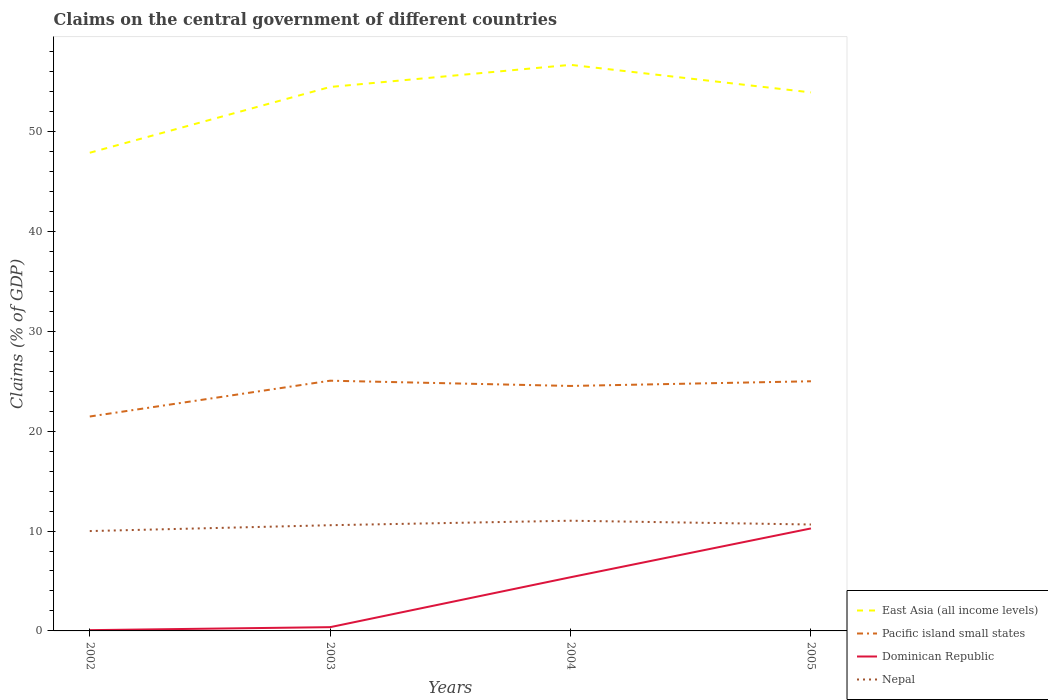How many different coloured lines are there?
Provide a short and direct response. 4. Does the line corresponding to East Asia (all income levels) intersect with the line corresponding to Nepal?
Your response must be concise. No. Across all years, what is the maximum percentage of GDP claimed on the central government in Pacific island small states?
Provide a short and direct response. 21.46. In which year was the percentage of GDP claimed on the central government in Nepal maximum?
Make the answer very short. 2002. What is the total percentage of GDP claimed on the central government in East Asia (all income levels) in the graph?
Your response must be concise. -2.21. What is the difference between the highest and the second highest percentage of GDP claimed on the central government in Pacific island small states?
Your answer should be compact. 3.58. What is the difference between the highest and the lowest percentage of GDP claimed on the central government in East Asia (all income levels)?
Make the answer very short. 3. How many lines are there?
Keep it short and to the point. 4. How many years are there in the graph?
Keep it short and to the point. 4. Are the values on the major ticks of Y-axis written in scientific E-notation?
Make the answer very short. No. Does the graph contain grids?
Offer a terse response. No. Where does the legend appear in the graph?
Keep it short and to the point. Bottom right. How many legend labels are there?
Provide a short and direct response. 4. What is the title of the graph?
Give a very brief answer. Claims on the central government of different countries. Does "Benin" appear as one of the legend labels in the graph?
Your answer should be very brief. No. What is the label or title of the X-axis?
Provide a short and direct response. Years. What is the label or title of the Y-axis?
Your answer should be very brief. Claims (% of GDP). What is the Claims (% of GDP) in East Asia (all income levels) in 2002?
Your answer should be very brief. 47.87. What is the Claims (% of GDP) of Pacific island small states in 2002?
Your response must be concise. 21.46. What is the Claims (% of GDP) in Dominican Republic in 2002?
Provide a succinct answer. 0.08. What is the Claims (% of GDP) of Nepal in 2002?
Provide a succinct answer. 10. What is the Claims (% of GDP) of East Asia (all income levels) in 2003?
Keep it short and to the point. 54.45. What is the Claims (% of GDP) in Pacific island small states in 2003?
Keep it short and to the point. 25.05. What is the Claims (% of GDP) in Dominican Republic in 2003?
Provide a short and direct response. 0.38. What is the Claims (% of GDP) in Nepal in 2003?
Give a very brief answer. 10.58. What is the Claims (% of GDP) in East Asia (all income levels) in 2004?
Your answer should be very brief. 56.67. What is the Claims (% of GDP) of Pacific island small states in 2004?
Keep it short and to the point. 24.52. What is the Claims (% of GDP) of Dominican Republic in 2004?
Your answer should be compact. 5.37. What is the Claims (% of GDP) of Nepal in 2004?
Ensure brevity in your answer.  11.03. What is the Claims (% of GDP) of East Asia (all income levels) in 2005?
Your response must be concise. 53.91. What is the Claims (% of GDP) of Pacific island small states in 2005?
Provide a succinct answer. 24.99. What is the Claims (% of GDP) of Dominican Republic in 2005?
Give a very brief answer. 10.26. What is the Claims (% of GDP) in Nepal in 2005?
Your response must be concise. 10.65. Across all years, what is the maximum Claims (% of GDP) of East Asia (all income levels)?
Keep it short and to the point. 56.67. Across all years, what is the maximum Claims (% of GDP) in Pacific island small states?
Make the answer very short. 25.05. Across all years, what is the maximum Claims (% of GDP) in Dominican Republic?
Give a very brief answer. 10.26. Across all years, what is the maximum Claims (% of GDP) in Nepal?
Your answer should be very brief. 11.03. Across all years, what is the minimum Claims (% of GDP) in East Asia (all income levels)?
Offer a very short reply. 47.87. Across all years, what is the minimum Claims (% of GDP) of Pacific island small states?
Offer a very short reply. 21.46. Across all years, what is the minimum Claims (% of GDP) in Dominican Republic?
Ensure brevity in your answer.  0.08. Across all years, what is the minimum Claims (% of GDP) in Nepal?
Give a very brief answer. 10. What is the total Claims (% of GDP) of East Asia (all income levels) in the graph?
Provide a short and direct response. 212.89. What is the total Claims (% of GDP) of Pacific island small states in the graph?
Your response must be concise. 96.02. What is the total Claims (% of GDP) of Dominican Republic in the graph?
Provide a succinct answer. 16.08. What is the total Claims (% of GDP) in Nepal in the graph?
Provide a short and direct response. 42.26. What is the difference between the Claims (% of GDP) of East Asia (all income levels) in 2002 and that in 2003?
Make the answer very short. -6.58. What is the difference between the Claims (% of GDP) of Pacific island small states in 2002 and that in 2003?
Your answer should be very brief. -3.58. What is the difference between the Claims (% of GDP) in Dominican Republic in 2002 and that in 2003?
Your answer should be very brief. -0.3. What is the difference between the Claims (% of GDP) of Nepal in 2002 and that in 2003?
Offer a very short reply. -0.59. What is the difference between the Claims (% of GDP) of East Asia (all income levels) in 2002 and that in 2004?
Offer a very short reply. -8.8. What is the difference between the Claims (% of GDP) in Pacific island small states in 2002 and that in 2004?
Provide a short and direct response. -3.06. What is the difference between the Claims (% of GDP) in Dominican Republic in 2002 and that in 2004?
Provide a succinct answer. -5.3. What is the difference between the Claims (% of GDP) in Nepal in 2002 and that in 2004?
Offer a terse response. -1.04. What is the difference between the Claims (% of GDP) of East Asia (all income levels) in 2002 and that in 2005?
Offer a terse response. -6.04. What is the difference between the Claims (% of GDP) of Pacific island small states in 2002 and that in 2005?
Give a very brief answer. -3.53. What is the difference between the Claims (% of GDP) in Dominican Republic in 2002 and that in 2005?
Your response must be concise. -10.18. What is the difference between the Claims (% of GDP) of Nepal in 2002 and that in 2005?
Your answer should be very brief. -0.66. What is the difference between the Claims (% of GDP) of East Asia (all income levels) in 2003 and that in 2004?
Make the answer very short. -2.21. What is the difference between the Claims (% of GDP) in Pacific island small states in 2003 and that in 2004?
Provide a short and direct response. 0.53. What is the difference between the Claims (% of GDP) of Dominican Republic in 2003 and that in 2004?
Provide a short and direct response. -5. What is the difference between the Claims (% of GDP) of Nepal in 2003 and that in 2004?
Your answer should be very brief. -0.45. What is the difference between the Claims (% of GDP) in East Asia (all income levels) in 2003 and that in 2005?
Offer a very short reply. 0.55. What is the difference between the Claims (% of GDP) in Pacific island small states in 2003 and that in 2005?
Make the answer very short. 0.06. What is the difference between the Claims (% of GDP) in Dominican Republic in 2003 and that in 2005?
Ensure brevity in your answer.  -9.88. What is the difference between the Claims (% of GDP) in Nepal in 2003 and that in 2005?
Offer a terse response. -0.07. What is the difference between the Claims (% of GDP) in East Asia (all income levels) in 2004 and that in 2005?
Make the answer very short. 2.76. What is the difference between the Claims (% of GDP) in Pacific island small states in 2004 and that in 2005?
Make the answer very short. -0.47. What is the difference between the Claims (% of GDP) of Dominican Republic in 2004 and that in 2005?
Give a very brief answer. -4.89. What is the difference between the Claims (% of GDP) of Nepal in 2004 and that in 2005?
Keep it short and to the point. 0.38. What is the difference between the Claims (% of GDP) in East Asia (all income levels) in 2002 and the Claims (% of GDP) in Pacific island small states in 2003?
Ensure brevity in your answer.  22.82. What is the difference between the Claims (% of GDP) in East Asia (all income levels) in 2002 and the Claims (% of GDP) in Dominican Republic in 2003?
Your answer should be compact. 47.49. What is the difference between the Claims (% of GDP) of East Asia (all income levels) in 2002 and the Claims (% of GDP) of Nepal in 2003?
Your answer should be compact. 37.28. What is the difference between the Claims (% of GDP) of Pacific island small states in 2002 and the Claims (% of GDP) of Dominican Republic in 2003?
Your response must be concise. 21.09. What is the difference between the Claims (% of GDP) in Pacific island small states in 2002 and the Claims (% of GDP) in Nepal in 2003?
Make the answer very short. 10.88. What is the difference between the Claims (% of GDP) in Dominican Republic in 2002 and the Claims (% of GDP) in Nepal in 2003?
Keep it short and to the point. -10.51. What is the difference between the Claims (% of GDP) of East Asia (all income levels) in 2002 and the Claims (% of GDP) of Pacific island small states in 2004?
Provide a succinct answer. 23.34. What is the difference between the Claims (% of GDP) of East Asia (all income levels) in 2002 and the Claims (% of GDP) of Dominican Republic in 2004?
Provide a succinct answer. 42.49. What is the difference between the Claims (% of GDP) in East Asia (all income levels) in 2002 and the Claims (% of GDP) in Nepal in 2004?
Keep it short and to the point. 36.83. What is the difference between the Claims (% of GDP) of Pacific island small states in 2002 and the Claims (% of GDP) of Dominican Republic in 2004?
Offer a very short reply. 16.09. What is the difference between the Claims (% of GDP) of Pacific island small states in 2002 and the Claims (% of GDP) of Nepal in 2004?
Keep it short and to the point. 10.43. What is the difference between the Claims (% of GDP) in Dominican Republic in 2002 and the Claims (% of GDP) in Nepal in 2004?
Your answer should be very brief. -10.96. What is the difference between the Claims (% of GDP) in East Asia (all income levels) in 2002 and the Claims (% of GDP) in Pacific island small states in 2005?
Your answer should be very brief. 22.88. What is the difference between the Claims (% of GDP) of East Asia (all income levels) in 2002 and the Claims (% of GDP) of Dominican Republic in 2005?
Make the answer very short. 37.61. What is the difference between the Claims (% of GDP) in East Asia (all income levels) in 2002 and the Claims (% of GDP) in Nepal in 2005?
Your answer should be compact. 37.21. What is the difference between the Claims (% of GDP) of Pacific island small states in 2002 and the Claims (% of GDP) of Dominican Republic in 2005?
Your answer should be compact. 11.2. What is the difference between the Claims (% of GDP) of Pacific island small states in 2002 and the Claims (% of GDP) of Nepal in 2005?
Offer a terse response. 10.81. What is the difference between the Claims (% of GDP) in Dominican Republic in 2002 and the Claims (% of GDP) in Nepal in 2005?
Your answer should be very brief. -10.58. What is the difference between the Claims (% of GDP) in East Asia (all income levels) in 2003 and the Claims (% of GDP) in Pacific island small states in 2004?
Provide a succinct answer. 29.93. What is the difference between the Claims (% of GDP) of East Asia (all income levels) in 2003 and the Claims (% of GDP) of Dominican Republic in 2004?
Give a very brief answer. 49.08. What is the difference between the Claims (% of GDP) of East Asia (all income levels) in 2003 and the Claims (% of GDP) of Nepal in 2004?
Keep it short and to the point. 43.42. What is the difference between the Claims (% of GDP) in Pacific island small states in 2003 and the Claims (% of GDP) in Dominican Republic in 2004?
Your answer should be compact. 19.68. What is the difference between the Claims (% of GDP) in Pacific island small states in 2003 and the Claims (% of GDP) in Nepal in 2004?
Provide a succinct answer. 14.02. What is the difference between the Claims (% of GDP) of Dominican Republic in 2003 and the Claims (% of GDP) of Nepal in 2004?
Provide a short and direct response. -10.66. What is the difference between the Claims (% of GDP) of East Asia (all income levels) in 2003 and the Claims (% of GDP) of Pacific island small states in 2005?
Offer a very short reply. 29.46. What is the difference between the Claims (% of GDP) in East Asia (all income levels) in 2003 and the Claims (% of GDP) in Dominican Republic in 2005?
Keep it short and to the point. 44.19. What is the difference between the Claims (% of GDP) in East Asia (all income levels) in 2003 and the Claims (% of GDP) in Nepal in 2005?
Keep it short and to the point. 43.8. What is the difference between the Claims (% of GDP) in Pacific island small states in 2003 and the Claims (% of GDP) in Dominican Republic in 2005?
Offer a terse response. 14.79. What is the difference between the Claims (% of GDP) in Pacific island small states in 2003 and the Claims (% of GDP) in Nepal in 2005?
Provide a succinct answer. 14.4. What is the difference between the Claims (% of GDP) of Dominican Republic in 2003 and the Claims (% of GDP) of Nepal in 2005?
Give a very brief answer. -10.28. What is the difference between the Claims (% of GDP) of East Asia (all income levels) in 2004 and the Claims (% of GDP) of Pacific island small states in 2005?
Your response must be concise. 31.67. What is the difference between the Claims (% of GDP) in East Asia (all income levels) in 2004 and the Claims (% of GDP) in Dominican Republic in 2005?
Your response must be concise. 46.41. What is the difference between the Claims (% of GDP) in East Asia (all income levels) in 2004 and the Claims (% of GDP) in Nepal in 2005?
Offer a terse response. 46.01. What is the difference between the Claims (% of GDP) in Pacific island small states in 2004 and the Claims (% of GDP) in Dominican Republic in 2005?
Give a very brief answer. 14.26. What is the difference between the Claims (% of GDP) in Pacific island small states in 2004 and the Claims (% of GDP) in Nepal in 2005?
Provide a short and direct response. 13.87. What is the difference between the Claims (% of GDP) in Dominican Republic in 2004 and the Claims (% of GDP) in Nepal in 2005?
Offer a very short reply. -5.28. What is the average Claims (% of GDP) in East Asia (all income levels) per year?
Ensure brevity in your answer.  53.22. What is the average Claims (% of GDP) of Pacific island small states per year?
Offer a very short reply. 24.01. What is the average Claims (% of GDP) of Dominican Republic per year?
Give a very brief answer. 4.02. What is the average Claims (% of GDP) of Nepal per year?
Your response must be concise. 10.57. In the year 2002, what is the difference between the Claims (% of GDP) of East Asia (all income levels) and Claims (% of GDP) of Pacific island small states?
Your response must be concise. 26.4. In the year 2002, what is the difference between the Claims (% of GDP) in East Asia (all income levels) and Claims (% of GDP) in Dominican Republic?
Your answer should be very brief. 47.79. In the year 2002, what is the difference between the Claims (% of GDP) in East Asia (all income levels) and Claims (% of GDP) in Nepal?
Make the answer very short. 37.87. In the year 2002, what is the difference between the Claims (% of GDP) in Pacific island small states and Claims (% of GDP) in Dominican Republic?
Your answer should be compact. 21.39. In the year 2002, what is the difference between the Claims (% of GDP) in Pacific island small states and Claims (% of GDP) in Nepal?
Offer a terse response. 11.47. In the year 2002, what is the difference between the Claims (% of GDP) of Dominican Republic and Claims (% of GDP) of Nepal?
Provide a succinct answer. -9.92. In the year 2003, what is the difference between the Claims (% of GDP) in East Asia (all income levels) and Claims (% of GDP) in Pacific island small states?
Your answer should be very brief. 29.4. In the year 2003, what is the difference between the Claims (% of GDP) of East Asia (all income levels) and Claims (% of GDP) of Dominican Republic?
Ensure brevity in your answer.  54.07. In the year 2003, what is the difference between the Claims (% of GDP) of East Asia (all income levels) and Claims (% of GDP) of Nepal?
Make the answer very short. 43.87. In the year 2003, what is the difference between the Claims (% of GDP) in Pacific island small states and Claims (% of GDP) in Dominican Republic?
Give a very brief answer. 24.67. In the year 2003, what is the difference between the Claims (% of GDP) in Pacific island small states and Claims (% of GDP) in Nepal?
Keep it short and to the point. 14.47. In the year 2003, what is the difference between the Claims (% of GDP) of Dominican Republic and Claims (% of GDP) of Nepal?
Your answer should be compact. -10.21. In the year 2004, what is the difference between the Claims (% of GDP) of East Asia (all income levels) and Claims (% of GDP) of Pacific island small states?
Make the answer very short. 32.14. In the year 2004, what is the difference between the Claims (% of GDP) of East Asia (all income levels) and Claims (% of GDP) of Dominican Republic?
Offer a terse response. 51.29. In the year 2004, what is the difference between the Claims (% of GDP) in East Asia (all income levels) and Claims (% of GDP) in Nepal?
Offer a very short reply. 45.63. In the year 2004, what is the difference between the Claims (% of GDP) of Pacific island small states and Claims (% of GDP) of Dominican Republic?
Your answer should be compact. 19.15. In the year 2004, what is the difference between the Claims (% of GDP) in Pacific island small states and Claims (% of GDP) in Nepal?
Provide a succinct answer. 13.49. In the year 2004, what is the difference between the Claims (% of GDP) of Dominican Republic and Claims (% of GDP) of Nepal?
Keep it short and to the point. -5.66. In the year 2005, what is the difference between the Claims (% of GDP) in East Asia (all income levels) and Claims (% of GDP) in Pacific island small states?
Keep it short and to the point. 28.91. In the year 2005, what is the difference between the Claims (% of GDP) in East Asia (all income levels) and Claims (% of GDP) in Dominican Republic?
Your answer should be very brief. 43.65. In the year 2005, what is the difference between the Claims (% of GDP) of East Asia (all income levels) and Claims (% of GDP) of Nepal?
Provide a short and direct response. 43.25. In the year 2005, what is the difference between the Claims (% of GDP) in Pacific island small states and Claims (% of GDP) in Dominican Republic?
Make the answer very short. 14.73. In the year 2005, what is the difference between the Claims (% of GDP) in Pacific island small states and Claims (% of GDP) in Nepal?
Give a very brief answer. 14.34. In the year 2005, what is the difference between the Claims (% of GDP) of Dominican Republic and Claims (% of GDP) of Nepal?
Offer a terse response. -0.39. What is the ratio of the Claims (% of GDP) in East Asia (all income levels) in 2002 to that in 2003?
Your answer should be very brief. 0.88. What is the ratio of the Claims (% of GDP) of Pacific island small states in 2002 to that in 2003?
Make the answer very short. 0.86. What is the ratio of the Claims (% of GDP) in Dominican Republic in 2002 to that in 2003?
Offer a very short reply. 0.2. What is the ratio of the Claims (% of GDP) in Nepal in 2002 to that in 2003?
Ensure brevity in your answer.  0.94. What is the ratio of the Claims (% of GDP) of East Asia (all income levels) in 2002 to that in 2004?
Provide a short and direct response. 0.84. What is the ratio of the Claims (% of GDP) of Pacific island small states in 2002 to that in 2004?
Provide a succinct answer. 0.88. What is the ratio of the Claims (% of GDP) of Dominican Republic in 2002 to that in 2004?
Offer a very short reply. 0.01. What is the ratio of the Claims (% of GDP) in Nepal in 2002 to that in 2004?
Give a very brief answer. 0.91. What is the ratio of the Claims (% of GDP) in East Asia (all income levels) in 2002 to that in 2005?
Your response must be concise. 0.89. What is the ratio of the Claims (% of GDP) in Pacific island small states in 2002 to that in 2005?
Your answer should be very brief. 0.86. What is the ratio of the Claims (% of GDP) of Dominican Republic in 2002 to that in 2005?
Offer a terse response. 0.01. What is the ratio of the Claims (% of GDP) in Nepal in 2002 to that in 2005?
Provide a succinct answer. 0.94. What is the ratio of the Claims (% of GDP) in East Asia (all income levels) in 2003 to that in 2004?
Ensure brevity in your answer.  0.96. What is the ratio of the Claims (% of GDP) of Pacific island small states in 2003 to that in 2004?
Your answer should be compact. 1.02. What is the ratio of the Claims (% of GDP) of Dominican Republic in 2003 to that in 2004?
Make the answer very short. 0.07. What is the ratio of the Claims (% of GDP) of Nepal in 2003 to that in 2004?
Make the answer very short. 0.96. What is the ratio of the Claims (% of GDP) in Dominican Republic in 2003 to that in 2005?
Your answer should be compact. 0.04. What is the ratio of the Claims (% of GDP) of East Asia (all income levels) in 2004 to that in 2005?
Ensure brevity in your answer.  1.05. What is the ratio of the Claims (% of GDP) in Pacific island small states in 2004 to that in 2005?
Ensure brevity in your answer.  0.98. What is the ratio of the Claims (% of GDP) of Dominican Republic in 2004 to that in 2005?
Your answer should be very brief. 0.52. What is the ratio of the Claims (% of GDP) of Nepal in 2004 to that in 2005?
Your answer should be very brief. 1.04. What is the difference between the highest and the second highest Claims (% of GDP) of East Asia (all income levels)?
Make the answer very short. 2.21. What is the difference between the highest and the second highest Claims (% of GDP) in Pacific island small states?
Make the answer very short. 0.06. What is the difference between the highest and the second highest Claims (% of GDP) in Dominican Republic?
Your answer should be very brief. 4.89. What is the difference between the highest and the second highest Claims (% of GDP) of Nepal?
Give a very brief answer. 0.38. What is the difference between the highest and the lowest Claims (% of GDP) of East Asia (all income levels)?
Your answer should be very brief. 8.8. What is the difference between the highest and the lowest Claims (% of GDP) in Pacific island small states?
Your answer should be very brief. 3.58. What is the difference between the highest and the lowest Claims (% of GDP) of Dominican Republic?
Offer a terse response. 10.18. What is the difference between the highest and the lowest Claims (% of GDP) of Nepal?
Ensure brevity in your answer.  1.04. 